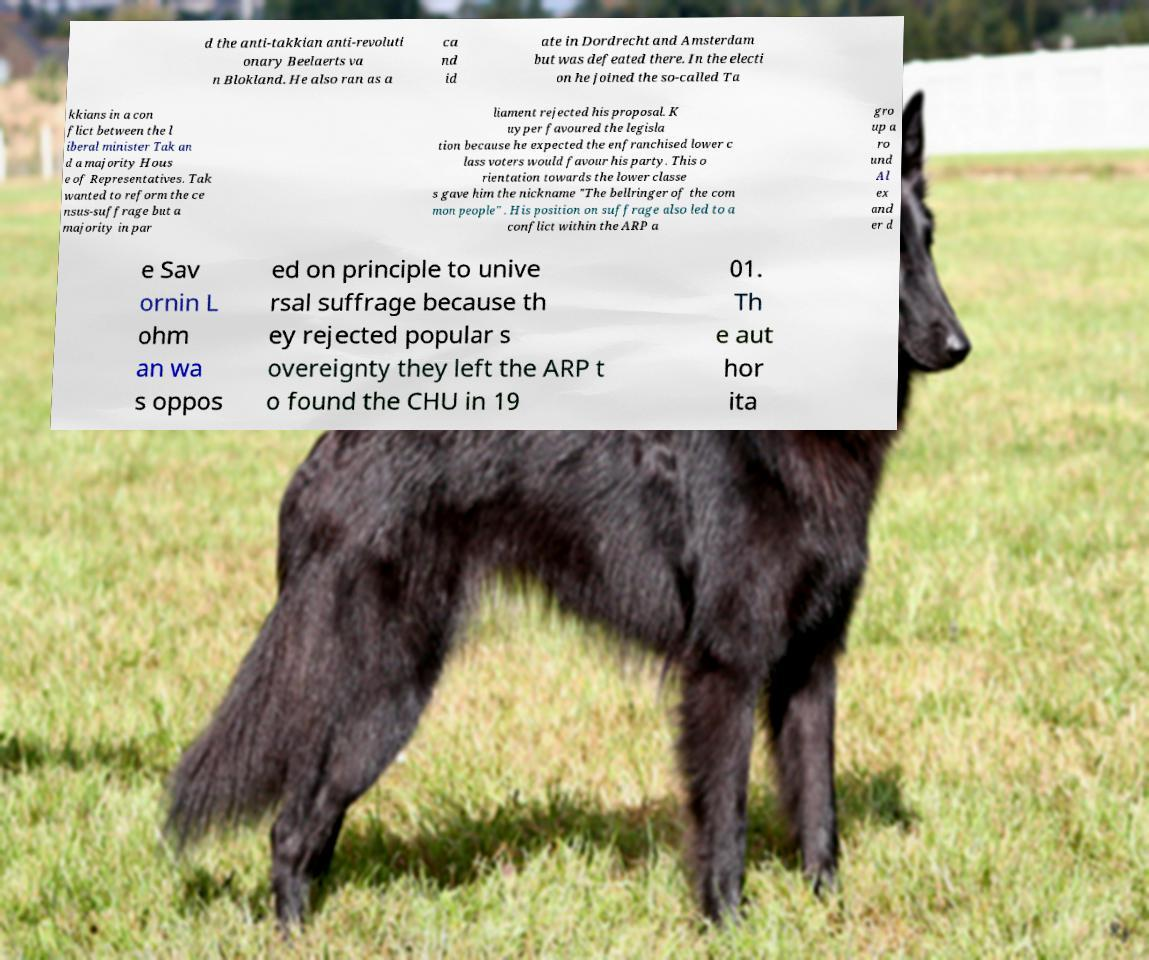There's text embedded in this image that I need extracted. Can you transcribe it verbatim? d the anti-takkian anti-revoluti onary Beelaerts va n Blokland. He also ran as a ca nd id ate in Dordrecht and Amsterdam but was defeated there. In the electi on he joined the so-called Ta kkians in a con flict between the l iberal minister Tak an d a majority Hous e of Representatives. Tak wanted to reform the ce nsus-suffrage but a majority in par liament rejected his proposal. K uyper favoured the legisla tion because he expected the enfranchised lower c lass voters would favour his party. This o rientation towards the lower classe s gave him the nickname "The bellringer of the com mon people" . His position on suffrage also led to a conflict within the ARP a gro up a ro und Al ex and er d e Sav ornin L ohm an wa s oppos ed on principle to unive rsal suffrage because th ey rejected popular s overeignty they left the ARP t o found the CHU in 19 01. Th e aut hor ita 